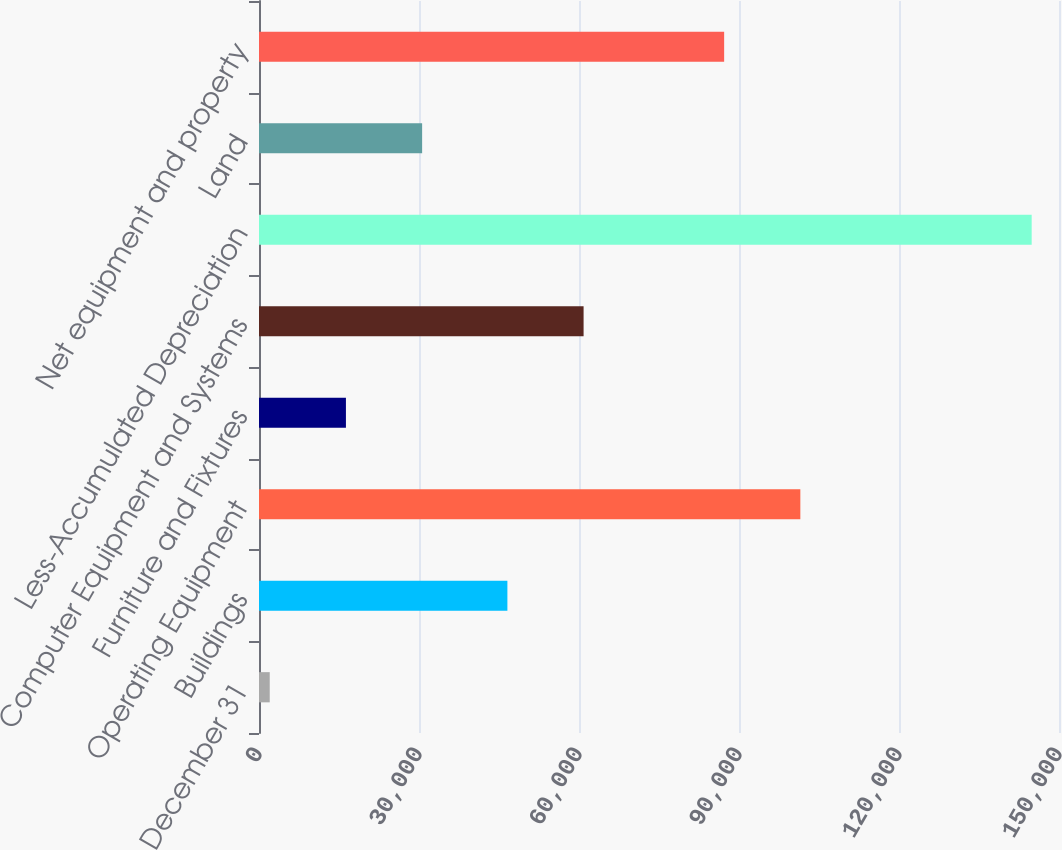<chart> <loc_0><loc_0><loc_500><loc_500><bar_chart><fcel>December 31<fcel>Buildings<fcel>Operating Equipment<fcel>Furniture and Fixtures<fcel>Computer Equipment and Systems<fcel>Less-Accumulated Depreciation<fcel>Land<fcel>Net equipment and property<nl><fcel>2013<fcel>46574<fcel>101501<fcel>16299.4<fcel>60860.4<fcel>144877<fcel>30585.8<fcel>87215<nl></chart> 